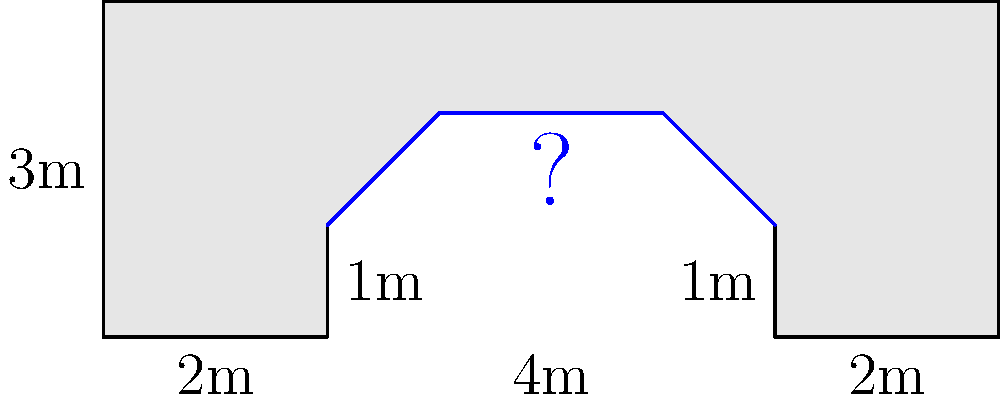As a firefighter with an interest in ancient civilizations, you're studying the cross-section of a Roman aqueduct. The diagram shows the aqueduct's dimensions and water level. What is the area of the water-filled section in square meters? To calculate the area of the water-filled section, we'll break it down into simple geometric shapes:

1. The water-filled section forms a trapezoid.

2. The height of the trapezoid is 1m (the vertical distance between the water surface and the bottom of the channel).

3. The bottom width of the trapezoid is 4m (the distance between the two lower corners of the water section).

4. The top width of the trapezoid is 2m (the length of the water surface).

5. The area of a trapezoid is given by the formula:
   $A = \frac{1}{2}(b_1 + b_2)h$
   Where $A$ is the area, $b_1$ and $b_2$ are the parallel sides, and $h$ is the height.

6. Substituting our values:
   $A = \frac{1}{2}(4m + 2m) \times 1m$

7. Simplifying:
   $A = \frac{1}{2} \times 6m \times 1m = 3m^2$

Therefore, the area of the water-filled section is 3 square meters.
Answer: $3m^2$ 